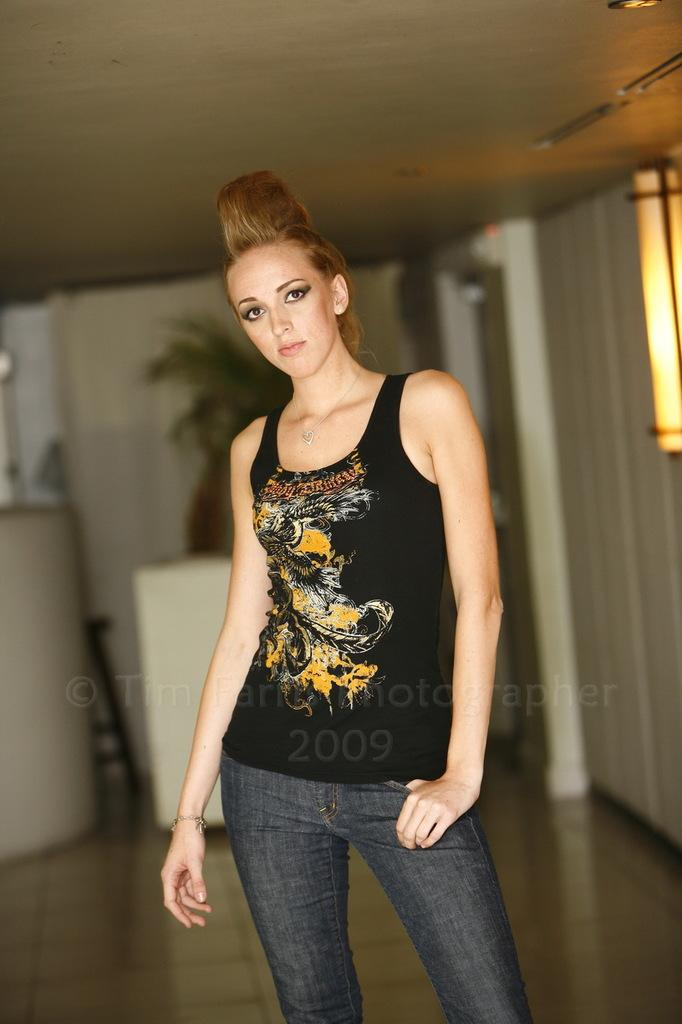What is the main subject of the image? There is a person standing in the image. Can you describe the lamp in the image? The lamp in the image is glowing. What can be seen in the background of the image? There are objects in the background of the image. What type of plant is present in the image? There is a house plant in the image. What type of bed can be seen in the image? There is no bed present in the image. Is there a battle taking place in the image? There is no battle depicted in the image. 